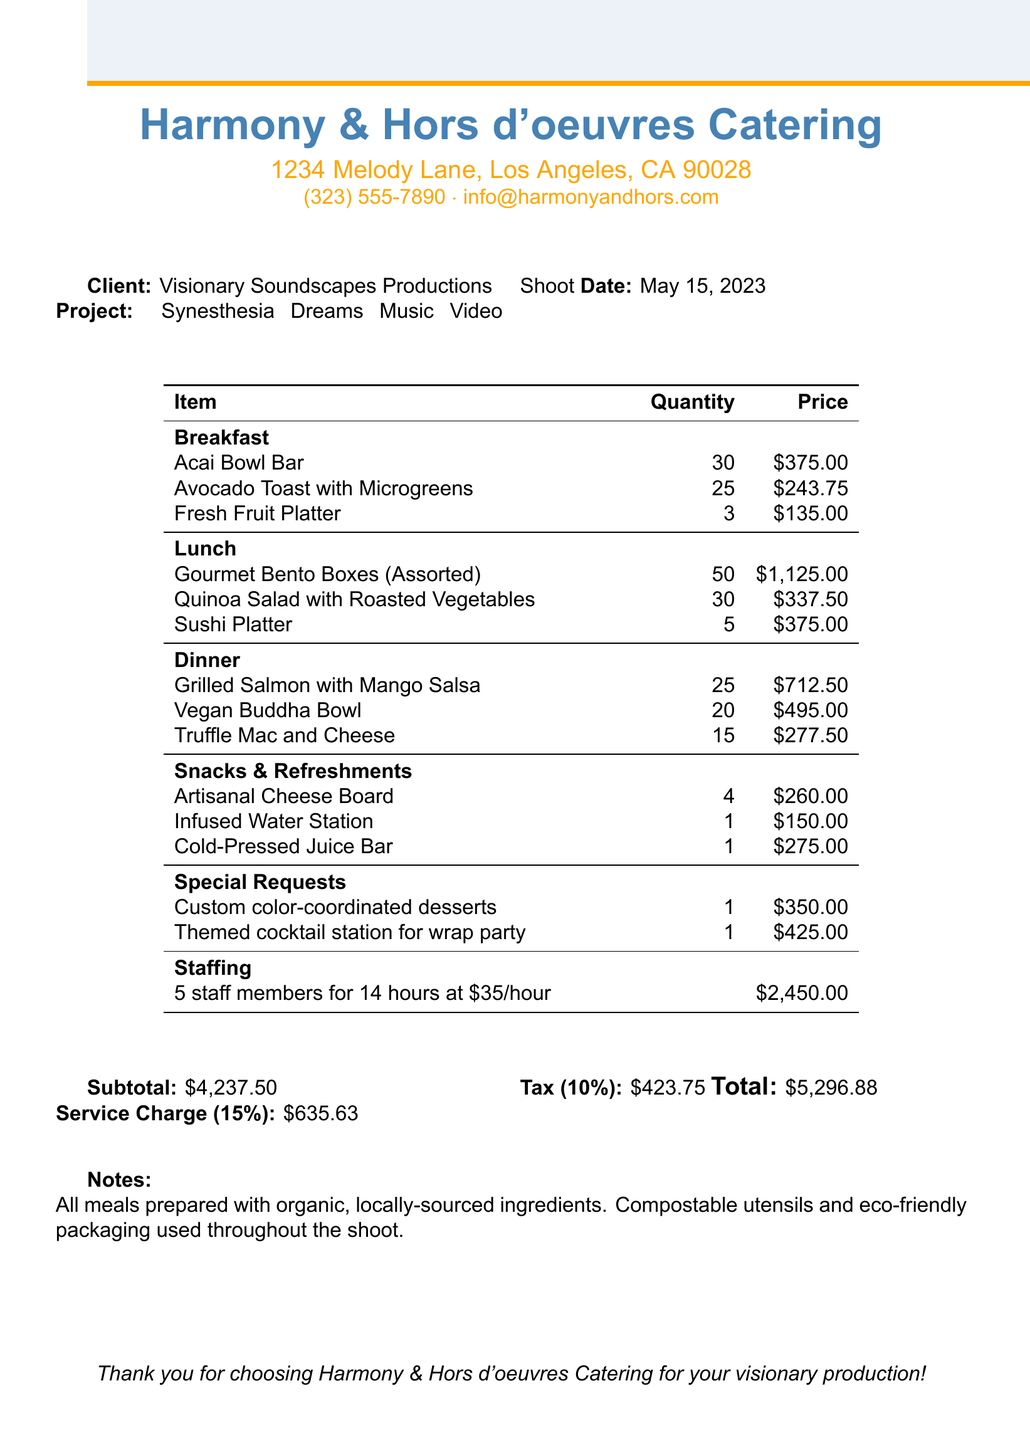What is the total amount of the invoice? The total amount is calculated as the sum of the subtotal, service charge, and tax listed in the document.
Answer: $5296.88 Who is the catering provider? The document specifies the name of the catering provider at the top.
Answer: Harmony & Hors d'oeuvres Catering What date was the catering service provided? The date is highlighted in the document, indicating when the service took place.
Answer: May 15, 2023 How many staff members were assigned to the event? The number of staff members is mentioned in the additional info section.
Answer: 5 What is the price per unit for Grilled Salmon with Mango Salsa? The price per unit for Grilled Salmon is listed in the dinner category.
Answer: $28.50 How many Gourmet Bento Boxes were ordered? This information can be found under the lunch category of the order details.
Answer: 50 What was the subtotal for the breakfast category? The subtotal for the breakfast category is calculated from the individual item prices and quantities.
Answer: $753.75 What special request involved a themed cocktail? The document lists special requests made for the event, including that for cocktails.
Answer: Themed cocktail station for wrap party What is the email contact for the catering company? The email address is provided in the header section of the receipt.
Answer: info@harmonyandhors.com 